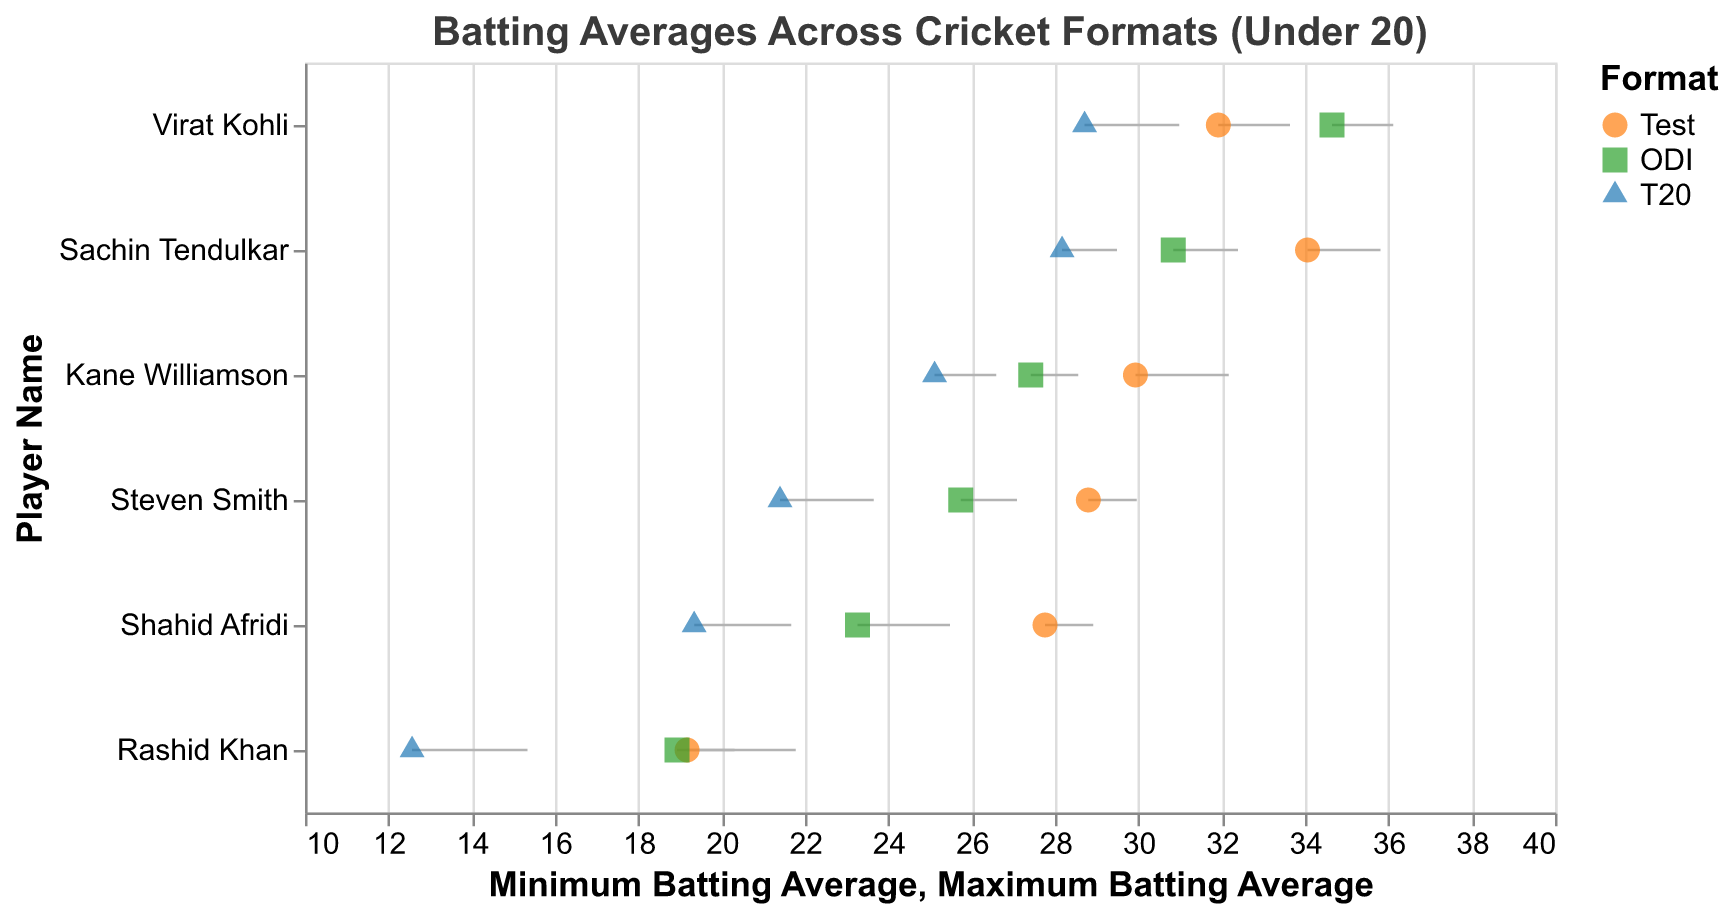How many players in total are represented in the plot? Count all unique player names present on the y-axis, which indicates each player's name
Answer: 6 Which player has the highest maximum batting average in any format? Look at the values for maximum batting average across all players and formats, then identify the highest value and the corresponding player
Answer: Virat Kohli For Virat Kohli, which format shows the highest minimum batting average? Compare the minimum batting averages for Virat Kohli across Test, ODI, and T20 formats by identifying the highest of the three values
Answer: ODI What's the average minimum batting average for Shahid Afridi across all formats? Sum Shahid Afridi's minimum batting averages for Test, ODI, and T20 (27.76 + 23.26 + 19.34) and divide by 3 to find the average
Answer: 23.45 Who has the lowest minimum batting average in T20 format and what is that value? Compare the minimum batting averages in the T20 format for all players and find the lowest value among them, identifying the player
Answer: Rashid Khan, 12.57 Which player shows the most consistent (least range) batting performance in the Test format? Calculate the range (difference between maximum and minimum) of batting averages for each player in the Test format and identify the one with the smallest range
Answer: Shahid Afridi Between Rashid Khan and Kane Williamson, who has a higher maximum batting average in the ODI format? Compare the maximum batting averages for Rashid Khan and Kane Williamson in the ODI format and see which value is greater
Answer: Kane Williamson What is the difference between Virat Kohli's minimum batting average in ODI and T20 formats? Subtract the minimum batting average of Virat Kohli in T20 (28.71) from his minimum in ODI (34.65)
Answer: 5.94 Which format generally shows the lowest batting averages across all players, based on the minimum values? Compare the minimum batting averages of all players in each format (Test, ODI, T20) to see which format has the lowest general batting averages
Answer: T20 Which player has the widest range of batting averages in the Test format? Calculate the range (difference between maximum and minimum) of batting averages for each player in the Test format and find the player with the widest range
Answer: Rashid Khan 